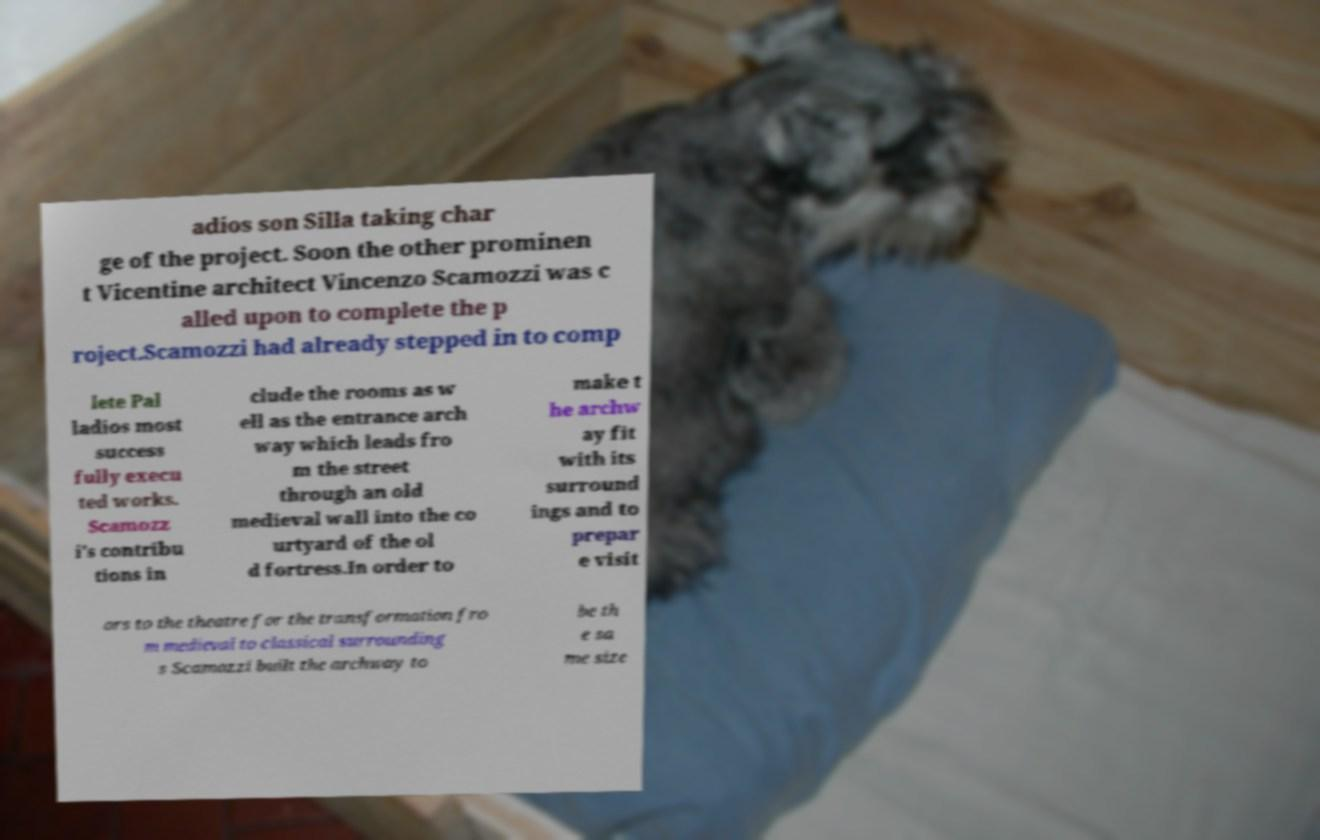There's text embedded in this image that I need extracted. Can you transcribe it verbatim? adios son Silla taking char ge of the project. Soon the other prominen t Vicentine architect Vincenzo Scamozzi was c alled upon to complete the p roject.Scamozzi had already stepped in to comp lete Pal ladios most success fully execu ted works. Scamozz i's contribu tions in clude the rooms as w ell as the entrance arch way which leads fro m the street through an old medieval wall into the co urtyard of the ol d fortress.In order to make t he archw ay fit with its surround ings and to prepar e visit ors to the theatre for the transformation fro m medieval to classical surrounding s Scamozzi built the archway to be th e sa me size 